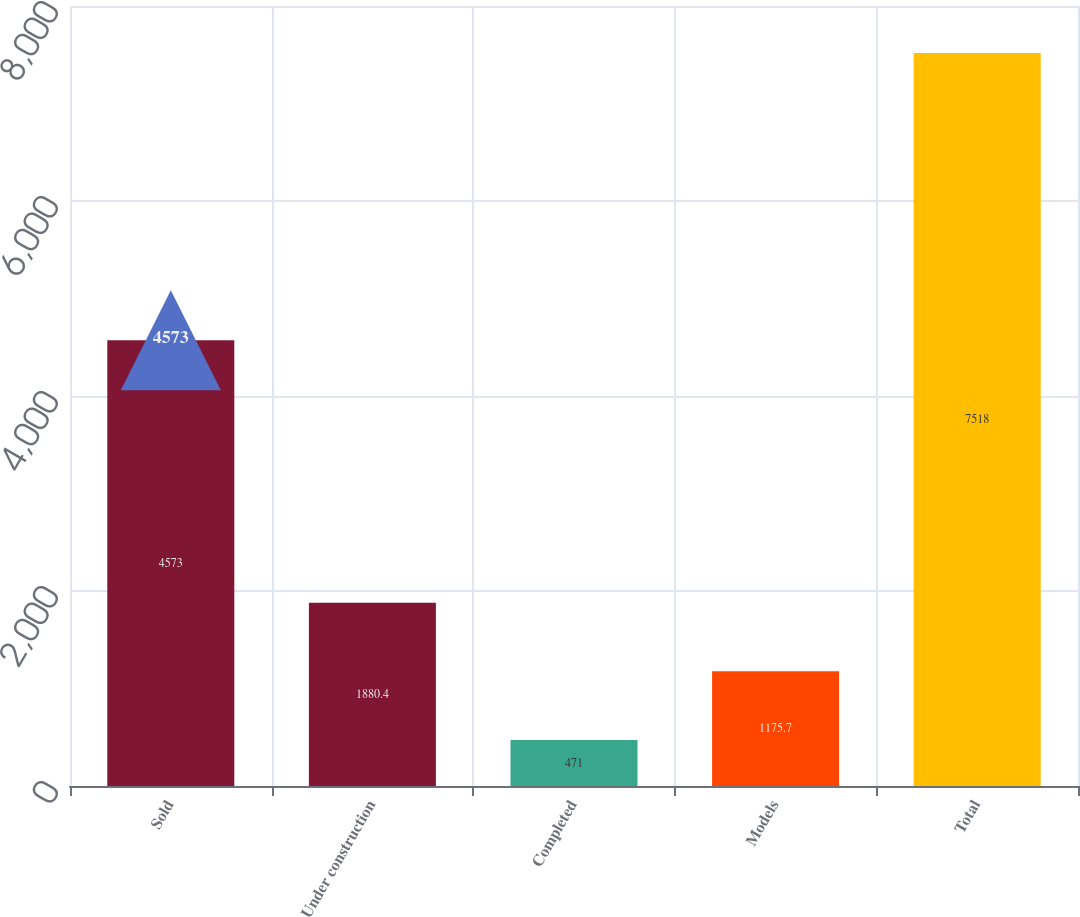<chart> <loc_0><loc_0><loc_500><loc_500><bar_chart><fcel>Sold<fcel>Under construction<fcel>Completed<fcel>Models<fcel>Total<nl><fcel>4573<fcel>1880.4<fcel>471<fcel>1175.7<fcel>7518<nl></chart> 